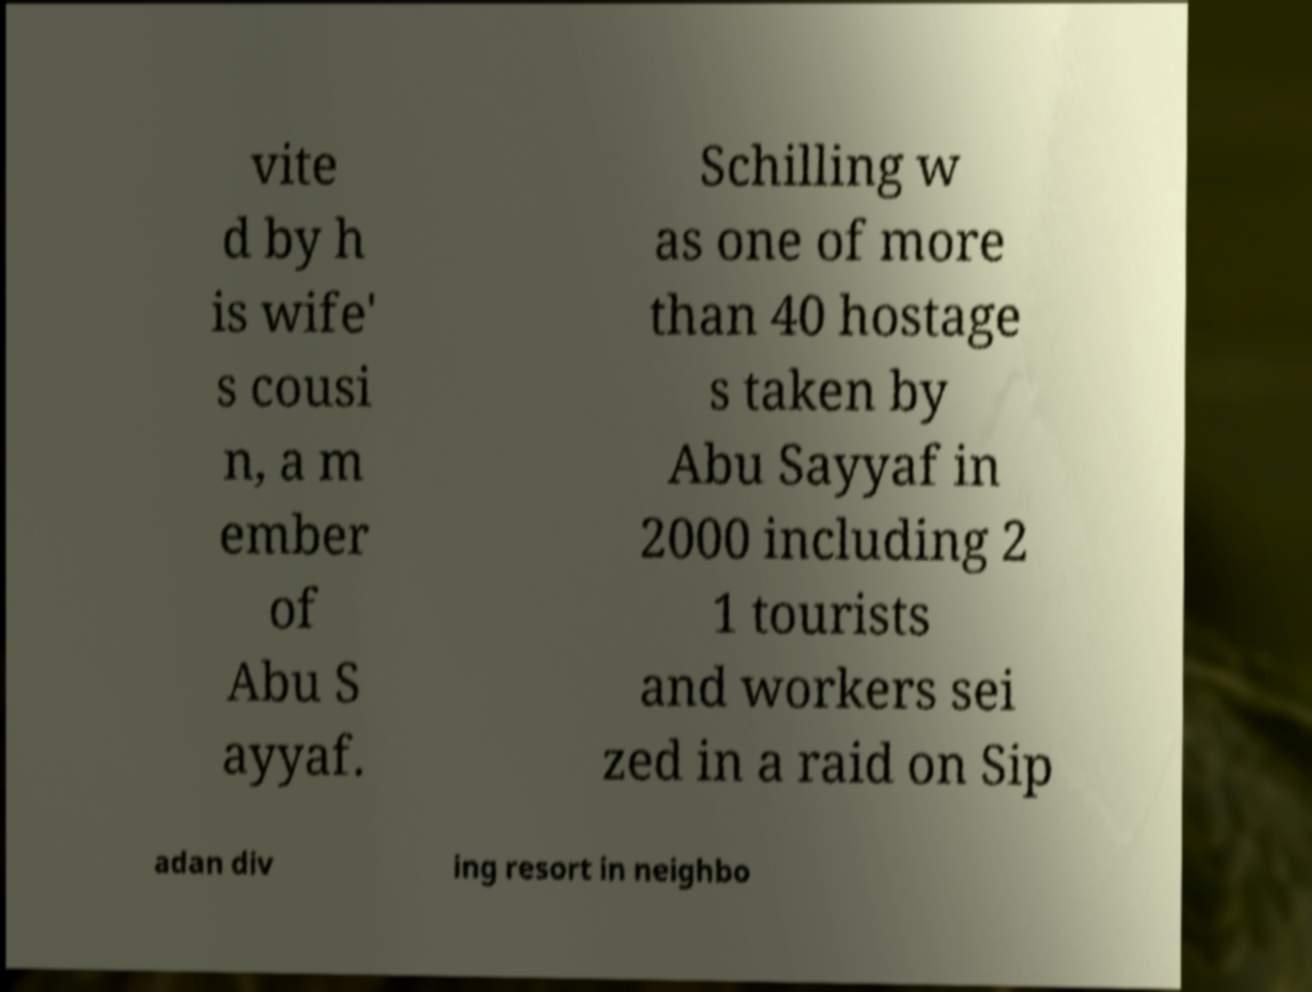Could you assist in decoding the text presented in this image and type it out clearly? vite d by h is wife' s cousi n, a m ember of Abu S ayyaf. Schilling w as one of more than 40 hostage s taken by Abu Sayyaf in 2000 including 2 1 tourists and workers sei zed in a raid on Sip adan div ing resort in neighbo 